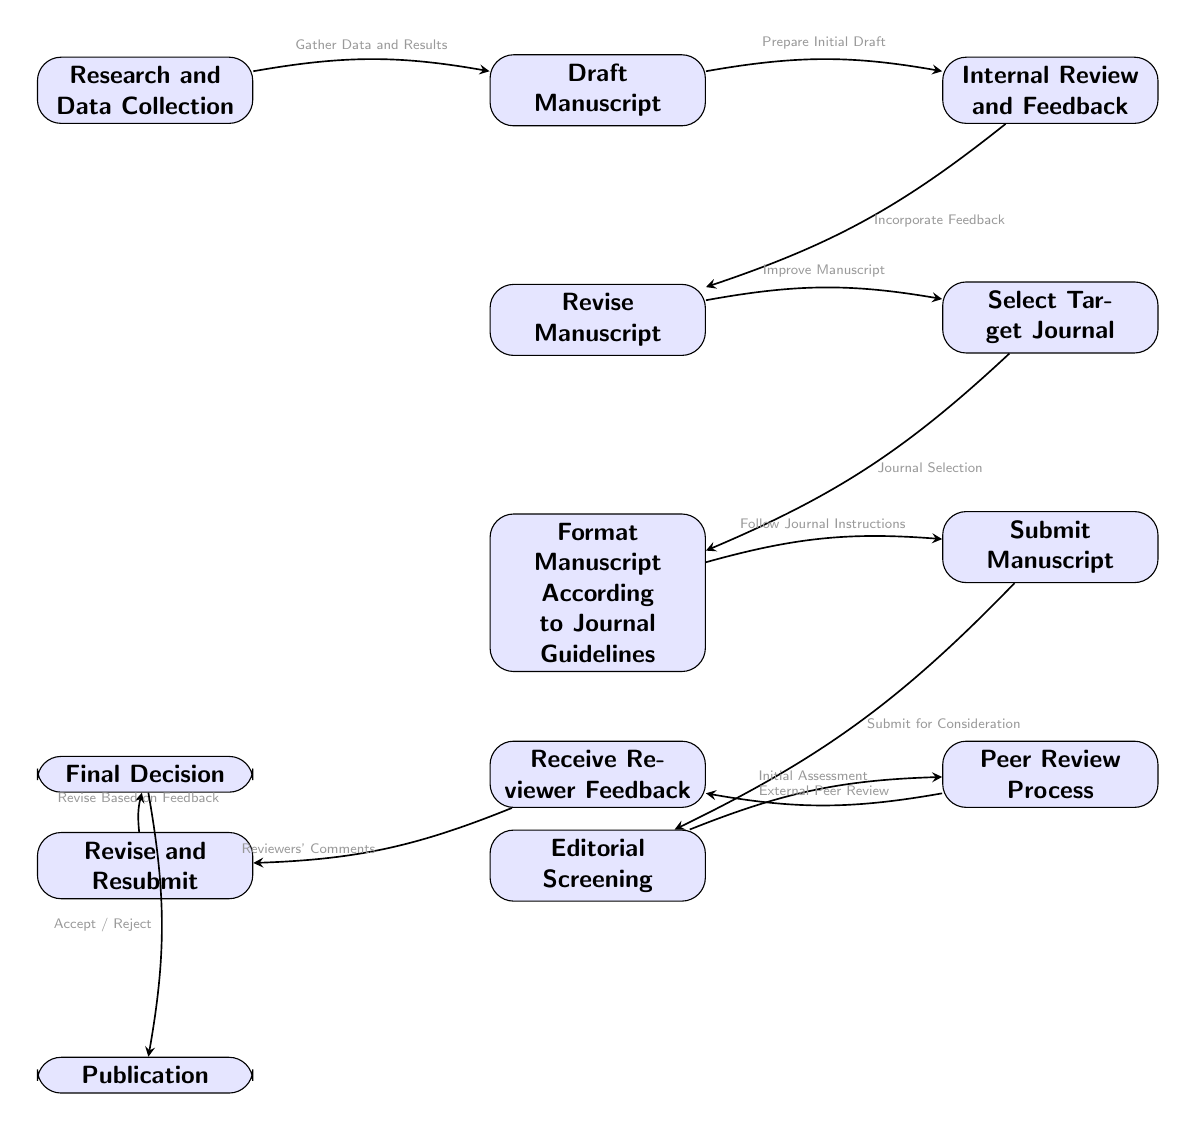What is the first step in the publication workflow? The first step is "Research and Data Collection", which is the top node in the diagram.
Answer: Research and Data Collection How many total steps are there in the publication workflow? By counting the nodes, there are 13 distinct steps or nodes illustrated in the workflow.
Answer: 13 What action is taken after the submission of the manuscript? After the "Submit Manuscript" node, the next step is "Editorial Screening", indicating the assessment that follows submission.
Answer: Editorial Screening Which node comes after "Select Target Journal"? The node that follows "Select Target Journal" is "Format Manuscript According to Journal Guidelines", showing the progression of steps in the workflow.
Answer: Format Manuscript According to Journal Guidelines What does the "Receive Reviewer Feedback" lead to? The "Receive Reviewer Feedback" node leads to "Revise and Resubmit", indicating the action taken after receiving the feedback from reviewers.
Answer: Revise and Resubmit What are the two possible outcomes after the "Final Decision" node? The outcomes after "Final Decision" are indicated as "Accept" or "Reject", which are the results of the editorial evaluation.
Answer: Accept / Reject Which step involves incorporating feedback from the internal review? The step that involves this action is "Revise Manuscript", which shows the process of using feedback to enhance the draft.
Answer: Revise Manuscript What is the relationship between "Peer Review Process" and "Receive Reviewer Feedback"? "Peer Review Process" leads to "Receive Reviewer Feedback," indicating that feedback is generated from the peer review stage.
Answer: Peer Review Process → Receive Reviewer Feedback What guidelines must be followed before submitting the manuscript? The guidelines to be followed are detailed in "Format Manuscript According to Journal Guidelines", which directs the author to adhere to specific formatting requirements.
Answer: Format Manuscript According to Journal Guidelines 